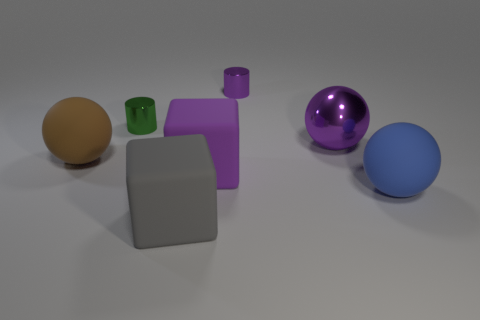Add 1 big blue rubber cylinders. How many objects exist? 8 Subtract all cylinders. How many objects are left? 5 Subtract all tiny green cylinders. Subtract all large matte blocks. How many objects are left? 4 Add 4 big objects. How many big objects are left? 9 Add 3 large objects. How many large objects exist? 8 Subtract 1 brown spheres. How many objects are left? 6 